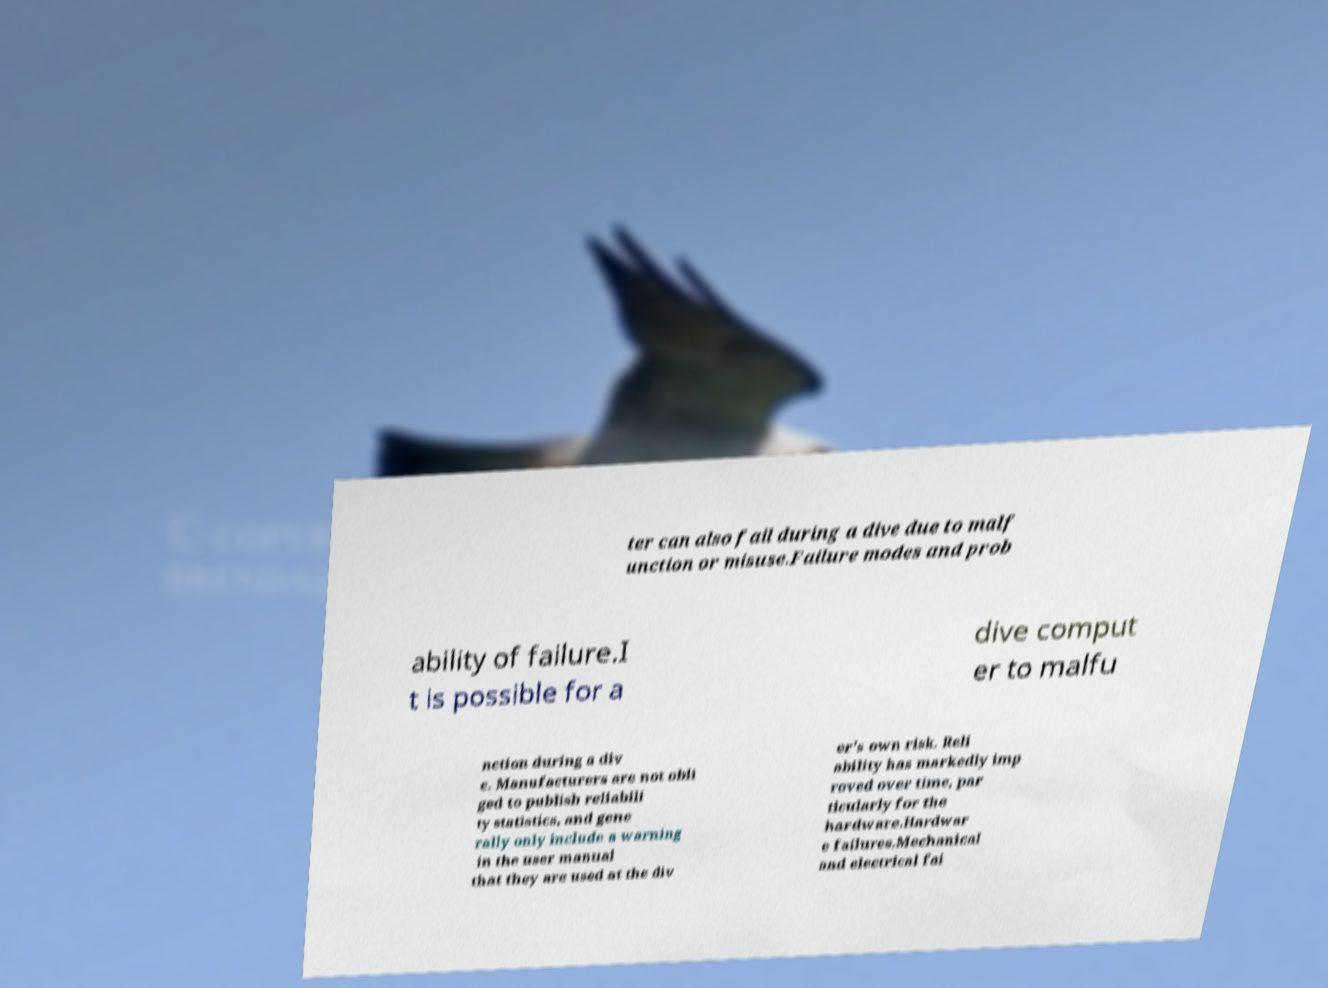Please identify and transcribe the text found in this image. ter can also fail during a dive due to malf unction or misuse.Failure modes and prob ability of failure.I t is possible for a dive comput er to malfu nction during a div e. Manufacturers are not obli ged to publish reliabili ty statistics, and gene rally only include a warning in the user manual that they are used at the div er's own risk. Reli ability has markedly imp roved over time, par ticularly for the hardware.Hardwar e failures.Mechanical and electrical fai 